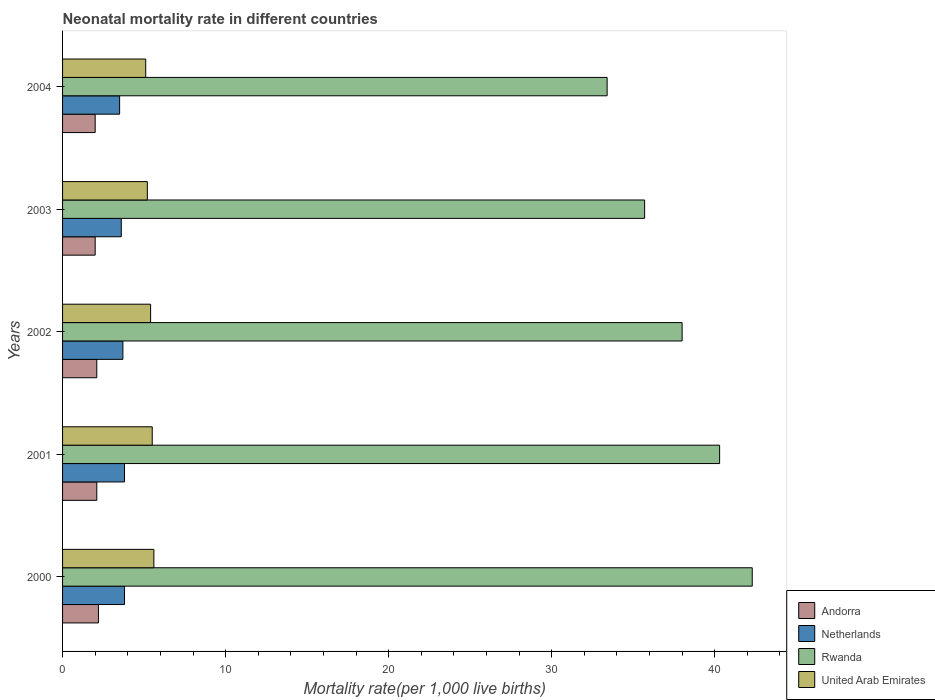How many different coloured bars are there?
Make the answer very short. 4. Are the number of bars per tick equal to the number of legend labels?
Ensure brevity in your answer.  Yes. In which year was the neonatal mortality rate in Rwanda maximum?
Ensure brevity in your answer.  2000. In which year was the neonatal mortality rate in Netherlands minimum?
Give a very brief answer. 2004. What is the difference between the neonatal mortality rate in Netherlands in 2001 and that in 2002?
Provide a succinct answer. 0.1. What is the average neonatal mortality rate in United Arab Emirates per year?
Offer a very short reply. 5.36. In the year 2000, what is the difference between the neonatal mortality rate in Rwanda and neonatal mortality rate in United Arab Emirates?
Provide a short and direct response. 36.7. In how many years, is the neonatal mortality rate in Rwanda greater than 40 ?
Give a very brief answer. 2. What is the difference between the highest and the second highest neonatal mortality rate in Netherlands?
Make the answer very short. 0. What is the difference between the highest and the lowest neonatal mortality rate in United Arab Emirates?
Provide a short and direct response. 0.5. In how many years, is the neonatal mortality rate in Andorra greater than the average neonatal mortality rate in Andorra taken over all years?
Your answer should be very brief. 3. Is the sum of the neonatal mortality rate in Rwanda in 2002 and 2004 greater than the maximum neonatal mortality rate in Netherlands across all years?
Make the answer very short. Yes. What does the 4th bar from the top in 2001 represents?
Provide a succinct answer. Andorra. What does the 1st bar from the bottom in 2003 represents?
Give a very brief answer. Andorra. Is it the case that in every year, the sum of the neonatal mortality rate in Andorra and neonatal mortality rate in United Arab Emirates is greater than the neonatal mortality rate in Netherlands?
Give a very brief answer. Yes. Are the values on the major ticks of X-axis written in scientific E-notation?
Offer a very short reply. No. Does the graph contain any zero values?
Make the answer very short. No. Does the graph contain grids?
Keep it short and to the point. No. How are the legend labels stacked?
Your answer should be very brief. Vertical. What is the title of the graph?
Your response must be concise. Neonatal mortality rate in different countries. What is the label or title of the X-axis?
Give a very brief answer. Mortality rate(per 1,0 live births). What is the label or title of the Y-axis?
Ensure brevity in your answer.  Years. What is the Mortality rate(per 1,000 live births) in Andorra in 2000?
Provide a short and direct response. 2.2. What is the Mortality rate(per 1,000 live births) of Rwanda in 2000?
Offer a terse response. 42.3. What is the Mortality rate(per 1,000 live births) of Rwanda in 2001?
Provide a succinct answer. 40.3. What is the Mortality rate(per 1,000 live births) in Netherlands in 2002?
Your answer should be compact. 3.7. What is the Mortality rate(per 1,000 live births) of Rwanda in 2003?
Give a very brief answer. 35.7. What is the Mortality rate(per 1,000 live births) in United Arab Emirates in 2003?
Make the answer very short. 5.2. What is the Mortality rate(per 1,000 live births) in Andorra in 2004?
Your answer should be very brief. 2. What is the Mortality rate(per 1,000 live births) of Rwanda in 2004?
Offer a terse response. 33.4. What is the Mortality rate(per 1,000 live births) of United Arab Emirates in 2004?
Offer a very short reply. 5.1. Across all years, what is the maximum Mortality rate(per 1,000 live births) in Netherlands?
Offer a very short reply. 3.8. Across all years, what is the maximum Mortality rate(per 1,000 live births) in Rwanda?
Your answer should be very brief. 42.3. Across all years, what is the minimum Mortality rate(per 1,000 live births) in Rwanda?
Offer a very short reply. 33.4. Across all years, what is the minimum Mortality rate(per 1,000 live births) in United Arab Emirates?
Your response must be concise. 5.1. What is the total Mortality rate(per 1,000 live births) of Netherlands in the graph?
Offer a very short reply. 18.4. What is the total Mortality rate(per 1,000 live births) in Rwanda in the graph?
Keep it short and to the point. 189.7. What is the total Mortality rate(per 1,000 live births) of United Arab Emirates in the graph?
Your answer should be compact. 26.8. What is the difference between the Mortality rate(per 1,000 live births) in Andorra in 2000 and that in 2001?
Ensure brevity in your answer.  0.1. What is the difference between the Mortality rate(per 1,000 live births) of Rwanda in 2000 and that in 2001?
Provide a short and direct response. 2. What is the difference between the Mortality rate(per 1,000 live births) in United Arab Emirates in 2000 and that in 2001?
Give a very brief answer. 0.1. What is the difference between the Mortality rate(per 1,000 live births) in Rwanda in 2000 and that in 2002?
Offer a terse response. 4.3. What is the difference between the Mortality rate(per 1,000 live births) of United Arab Emirates in 2000 and that in 2002?
Provide a short and direct response. 0.2. What is the difference between the Mortality rate(per 1,000 live births) in Andorra in 2000 and that in 2003?
Provide a short and direct response. 0.2. What is the difference between the Mortality rate(per 1,000 live births) in Netherlands in 2000 and that in 2003?
Provide a short and direct response. 0.2. What is the difference between the Mortality rate(per 1,000 live births) in Netherlands in 2000 and that in 2004?
Give a very brief answer. 0.3. What is the difference between the Mortality rate(per 1,000 live births) of United Arab Emirates in 2001 and that in 2002?
Offer a very short reply. 0.1. What is the difference between the Mortality rate(per 1,000 live births) of Andorra in 2001 and that in 2003?
Your answer should be compact. 0.1. What is the difference between the Mortality rate(per 1,000 live births) in Netherlands in 2001 and that in 2003?
Provide a succinct answer. 0.2. What is the difference between the Mortality rate(per 1,000 live births) in Andorra in 2001 and that in 2004?
Offer a very short reply. 0.1. What is the difference between the Mortality rate(per 1,000 live births) of Rwanda in 2001 and that in 2004?
Make the answer very short. 6.9. What is the difference between the Mortality rate(per 1,000 live births) of United Arab Emirates in 2001 and that in 2004?
Your response must be concise. 0.4. What is the difference between the Mortality rate(per 1,000 live births) in Andorra in 2002 and that in 2003?
Your response must be concise. 0.1. What is the difference between the Mortality rate(per 1,000 live births) in Netherlands in 2002 and that in 2003?
Provide a short and direct response. 0.1. What is the difference between the Mortality rate(per 1,000 live births) of United Arab Emirates in 2002 and that in 2003?
Ensure brevity in your answer.  0.2. What is the difference between the Mortality rate(per 1,000 live births) in United Arab Emirates in 2002 and that in 2004?
Provide a succinct answer. 0.3. What is the difference between the Mortality rate(per 1,000 live births) in Andorra in 2003 and that in 2004?
Provide a short and direct response. 0. What is the difference between the Mortality rate(per 1,000 live births) in Netherlands in 2003 and that in 2004?
Ensure brevity in your answer.  0.1. What is the difference between the Mortality rate(per 1,000 live births) in Rwanda in 2003 and that in 2004?
Offer a very short reply. 2.3. What is the difference between the Mortality rate(per 1,000 live births) in Andorra in 2000 and the Mortality rate(per 1,000 live births) in Netherlands in 2001?
Offer a very short reply. -1.6. What is the difference between the Mortality rate(per 1,000 live births) of Andorra in 2000 and the Mortality rate(per 1,000 live births) of Rwanda in 2001?
Your answer should be very brief. -38.1. What is the difference between the Mortality rate(per 1,000 live births) in Netherlands in 2000 and the Mortality rate(per 1,000 live births) in Rwanda in 2001?
Your answer should be very brief. -36.5. What is the difference between the Mortality rate(per 1,000 live births) of Netherlands in 2000 and the Mortality rate(per 1,000 live births) of United Arab Emirates in 2001?
Keep it short and to the point. -1.7. What is the difference between the Mortality rate(per 1,000 live births) in Rwanda in 2000 and the Mortality rate(per 1,000 live births) in United Arab Emirates in 2001?
Your response must be concise. 36.8. What is the difference between the Mortality rate(per 1,000 live births) of Andorra in 2000 and the Mortality rate(per 1,000 live births) of Netherlands in 2002?
Provide a short and direct response. -1.5. What is the difference between the Mortality rate(per 1,000 live births) in Andorra in 2000 and the Mortality rate(per 1,000 live births) in Rwanda in 2002?
Provide a short and direct response. -35.8. What is the difference between the Mortality rate(per 1,000 live births) in Andorra in 2000 and the Mortality rate(per 1,000 live births) in United Arab Emirates in 2002?
Your answer should be very brief. -3.2. What is the difference between the Mortality rate(per 1,000 live births) in Netherlands in 2000 and the Mortality rate(per 1,000 live births) in Rwanda in 2002?
Keep it short and to the point. -34.2. What is the difference between the Mortality rate(per 1,000 live births) of Rwanda in 2000 and the Mortality rate(per 1,000 live births) of United Arab Emirates in 2002?
Offer a very short reply. 36.9. What is the difference between the Mortality rate(per 1,000 live births) of Andorra in 2000 and the Mortality rate(per 1,000 live births) of Netherlands in 2003?
Give a very brief answer. -1.4. What is the difference between the Mortality rate(per 1,000 live births) of Andorra in 2000 and the Mortality rate(per 1,000 live births) of Rwanda in 2003?
Offer a terse response. -33.5. What is the difference between the Mortality rate(per 1,000 live births) in Andorra in 2000 and the Mortality rate(per 1,000 live births) in United Arab Emirates in 2003?
Offer a terse response. -3. What is the difference between the Mortality rate(per 1,000 live births) in Netherlands in 2000 and the Mortality rate(per 1,000 live births) in Rwanda in 2003?
Offer a very short reply. -31.9. What is the difference between the Mortality rate(per 1,000 live births) in Netherlands in 2000 and the Mortality rate(per 1,000 live births) in United Arab Emirates in 2003?
Provide a short and direct response. -1.4. What is the difference between the Mortality rate(per 1,000 live births) of Rwanda in 2000 and the Mortality rate(per 1,000 live births) of United Arab Emirates in 2003?
Your response must be concise. 37.1. What is the difference between the Mortality rate(per 1,000 live births) of Andorra in 2000 and the Mortality rate(per 1,000 live births) of Netherlands in 2004?
Your response must be concise. -1.3. What is the difference between the Mortality rate(per 1,000 live births) in Andorra in 2000 and the Mortality rate(per 1,000 live births) in Rwanda in 2004?
Provide a succinct answer. -31.2. What is the difference between the Mortality rate(per 1,000 live births) of Netherlands in 2000 and the Mortality rate(per 1,000 live births) of Rwanda in 2004?
Make the answer very short. -29.6. What is the difference between the Mortality rate(per 1,000 live births) of Rwanda in 2000 and the Mortality rate(per 1,000 live births) of United Arab Emirates in 2004?
Keep it short and to the point. 37.2. What is the difference between the Mortality rate(per 1,000 live births) of Andorra in 2001 and the Mortality rate(per 1,000 live births) of Rwanda in 2002?
Your response must be concise. -35.9. What is the difference between the Mortality rate(per 1,000 live births) of Netherlands in 2001 and the Mortality rate(per 1,000 live births) of Rwanda in 2002?
Your answer should be very brief. -34.2. What is the difference between the Mortality rate(per 1,000 live births) in Netherlands in 2001 and the Mortality rate(per 1,000 live births) in United Arab Emirates in 2002?
Keep it short and to the point. -1.6. What is the difference between the Mortality rate(per 1,000 live births) of Rwanda in 2001 and the Mortality rate(per 1,000 live births) of United Arab Emirates in 2002?
Offer a terse response. 34.9. What is the difference between the Mortality rate(per 1,000 live births) of Andorra in 2001 and the Mortality rate(per 1,000 live births) of Rwanda in 2003?
Your answer should be compact. -33.6. What is the difference between the Mortality rate(per 1,000 live births) in Andorra in 2001 and the Mortality rate(per 1,000 live births) in United Arab Emirates in 2003?
Your answer should be compact. -3.1. What is the difference between the Mortality rate(per 1,000 live births) of Netherlands in 2001 and the Mortality rate(per 1,000 live births) of Rwanda in 2003?
Provide a succinct answer. -31.9. What is the difference between the Mortality rate(per 1,000 live births) in Netherlands in 2001 and the Mortality rate(per 1,000 live births) in United Arab Emirates in 2003?
Your answer should be compact. -1.4. What is the difference between the Mortality rate(per 1,000 live births) in Rwanda in 2001 and the Mortality rate(per 1,000 live births) in United Arab Emirates in 2003?
Offer a terse response. 35.1. What is the difference between the Mortality rate(per 1,000 live births) of Andorra in 2001 and the Mortality rate(per 1,000 live births) of Rwanda in 2004?
Your answer should be compact. -31.3. What is the difference between the Mortality rate(per 1,000 live births) in Andorra in 2001 and the Mortality rate(per 1,000 live births) in United Arab Emirates in 2004?
Keep it short and to the point. -3. What is the difference between the Mortality rate(per 1,000 live births) of Netherlands in 2001 and the Mortality rate(per 1,000 live births) of Rwanda in 2004?
Give a very brief answer. -29.6. What is the difference between the Mortality rate(per 1,000 live births) in Netherlands in 2001 and the Mortality rate(per 1,000 live births) in United Arab Emirates in 2004?
Provide a short and direct response. -1.3. What is the difference between the Mortality rate(per 1,000 live births) of Rwanda in 2001 and the Mortality rate(per 1,000 live births) of United Arab Emirates in 2004?
Your response must be concise. 35.2. What is the difference between the Mortality rate(per 1,000 live births) of Andorra in 2002 and the Mortality rate(per 1,000 live births) of Rwanda in 2003?
Your answer should be very brief. -33.6. What is the difference between the Mortality rate(per 1,000 live births) in Netherlands in 2002 and the Mortality rate(per 1,000 live births) in Rwanda in 2003?
Ensure brevity in your answer.  -32. What is the difference between the Mortality rate(per 1,000 live births) of Netherlands in 2002 and the Mortality rate(per 1,000 live births) of United Arab Emirates in 2003?
Your response must be concise. -1.5. What is the difference between the Mortality rate(per 1,000 live births) of Rwanda in 2002 and the Mortality rate(per 1,000 live births) of United Arab Emirates in 2003?
Provide a succinct answer. 32.8. What is the difference between the Mortality rate(per 1,000 live births) of Andorra in 2002 and the Mortality rate(per 1,000 live births) of Rwanda in 2004?
Your answer should be compact. -31.3. What is the difference between the Mortality rate(per 1,000 live births) in Netherlands in 2002 and the Mortality rate(per 1,000 live births) in Rwanda in 2004?
Give a very brief answer. -29.7. What is the difference between the Mortality rate(per 1,000 live births) of Netherlands in 2002 and the Mortality rate(per 1,000 live births) of United Arab Emirates in 2004?
Make the answer very short. -1.4. What is the difference between the Mortality rate(per 1,000 live births) in Rwanda in 2002 and the Mortality rate(per 1,000 live births) in United Arab Emirates in 2004?
Ensure brevity in your answer.  32.9. What is the difference between the Mortality rate(per 1,000 live births) in Andorra in 2003 and the Mortality rate(per 1,000 live births) in Netherlands in 2004?
Keep it short and to the point. -1.5. What is the difference between the Mortality rate(per 1,000 live births) of Andorra in 2003 and the Mortality rate(per 1,000 live births) of Rwanda in 2004?
Ensure brevity in your answer.  -31.4. What is the difference between the Mortality rate(per 1,000 live births) of Netherlands in 2003 and the Mortality rate(per 1,000 live births) of Rwanda in 2004?
Your response must be concise. -29.8. What is the difference between the Mortality rate(per 1,000 live births) of Rwanda in 2003 and the Mortality rate(per 1,000 live births) of United Arab Emirates in 2004?
Make the answer very short. 30.6. What is the average Mortality rate(per 1,000 live births) of Andorra per year?
Your answer should be compact. 2.08. What is the average Mortality rate(per 1,000 live births) in Netherlands per year?
Offer a terse response. 3.68. What is the average Mortality rate(per 1,000 live births) of Rwanda per year?
Your answer should be compact. 37.94. What is the average Mortality rate(per 1,000 live births) of United Arab Emirates per year?
Keep it short and to the point. 5.36. In the year 2000, what is the difference between the Mortality rate(per 1,000 live births) in Andorra and Mortality rate(per 1,000 live births) in Netherlands?
Offer a terse response. -1.6. In the year 2000, what is the difference between the Mortality rate(per 1,000 live births) of Andorra and Mortality rate(per 1,000 live births) of Rwanda?
Provide a short and direct response. -40.1. In the year 2000, what is the difference between the Mortality rate(per 1,000 live births) in Andorra and Mortality rate(per 1,000 live births) in United Arab Emirates?
Make the answer very short. -3.4. In the year 2000, what is the difference between the Mortality rate(per 1,000 live births) of Netherlands and Mortality rate(per 1,000 live births) of Rwanda?
Ensure brevity in your answer.  -38.5. In the year 2000, what is the difference between the Mortality rate(per 1,000 live births) of Netherlands and Mortality rate(per 1,000 live births) of United Arab Emirates?
Provide a succinct answer. -1.8. In the year 2000, what is the difference between the Mortality rate(per 1,000 live births) in Rwanda and Mortality rate(per 1,000 live births) in United Arab Emirates?
Your answer should be compact. 36.7. In the year 2001, what is the difference between the Mortality rate(per 1,000 live births) of Andorra and Mortality rate(per 1,000 live births) of Netherlands?
Your answer should be compact. -1.7. In the year 2001, what is the difference between the Mortality rate(per 1,000 live births) of Andorra and Mortality rate(per 1,000 live births) of Rwanda?
Provide a short and direct response. -38.2. In the year 2001, what is the difference between the Mortality rate(per 1,000 live births) of Andorra and Mortality rate(per 1,000 live births) of United Arab Emirates?
Offer a very short reply. -3.4. In the year 2001, what is the difference between the Mortality rate(per 1,000 live births) of Netherlands and Mortality rate(per 1,000 live births) of Rwanda?
Your answer should be very brief. -36.5. In the year 2001, what is the difference between the Mortality rate(per 1,000 live births) in Rwanda and Mortality rate(per 1,000 live births) in United Arab Emirates?
Provide a succinct answer. 34.8. In the year 2002, what is the difference between the Mortality rate(per 1,000 live births) of Andorra and Mortality rate(per 1,000 live births) of Rwanda?
Ensure brevity in your answer.  -35.9. In the year 2002, what is the difference between the Mortality rate(per 1,000 live births) in Netherlands and Mortality rate(per 1,000 live births) in Rwanda?
Your answer should be very brief. -34.3. In the year 2002, what is the difference between the Mortality rate(per 1,000 live births) of Netherlands and Mortality rate(per 1,000 live births) of United Arab Emirates?
Offer a very short reply. -1.7. In the year 2002, what is the difference between the Mortality rate(per 1,000 live births) of Rwanda and Mortality rate(per 1,000 live births) of United Arab Emirates?
Your answer should be compact. 32.6. In the year 2003, what is the difference between the Mortality rate(per 1,000 live births) in Andorra and Mortality rate(per 1,000 live births) in Netherlands?
Your answer should be compact. -1.6. In the year 2003, what is the difference between the Mortality rate(per 1,000 live births) of Andorra and Mortality rate(per 1,000 live births) of Rwanda?
Make the answer very short. -33.7. In the year 2003, what is the difference between the Mortality rate(per 1,000 live births) in Netherlands and Mortality rate(per 1,000 live births) in Rwanda?
Your answer should be very brief. -32.1. In the year 2003, what is the difference between the Mortality rate(per 1,000 live births) in Netherlands and Mortality rate(per 1,000 live births) in United Arab Emirates?
Provide a short and direct response. -1.6. In the year 2003, what is the difference between the Mortality rate(per 1,000 live births) of Rwanda and Mortality rate(per 1,000 live births) of United Arab Emirates?
Your response must be concise. 30.5. In the year 2004, what is the difference between the Mortality rate(per 1,000 live births) of Andorra and Mortality rate(per 1,000 live births) of Netherlands?
Ensure brevity in your answer.  -1.5. In the year 2004, what is the difference between the Mortality rate(per 1,000 live births) in Andorra and Mortality rate(per 1,000 live births) in Rwanda?
Provide a succinct answer. -31.4. In the year 2004, what is the difference between the Mortality rate(per 1,000 live births) of Netherlands and Mortality rate(per 1,000 live births) of Rwanda?
Your response must be concise. -29.9. In the year 2004, what is the difference between the Mortality rate(per 1,000 live births) in Netherlands and Mortality rate(per 1,000 live births) in United Arab Emirates?
Your answer should be compact. -1.6. In the year 2004, what is the difference between the Mortality rate(per 1,000 live births) in Rwanda and Mortality rate(per 1,000 live births) in United Arab Emirates?
Keep it short and to the point. 28.3. What is the ratio of the Mortality rate(per 1,000 live births) in Andorra in 2000 to that in 2001?
Your response must be concise. 1.05. What is the ratio of the Mortality rate(per 1,000 live births) of Rwanda in 2000 to that in 2001?
Offer a very short reply. 1.05. What is the ratio of the Mortality rate(per 1,000 live births) in United Arab Emirates in 2000 to that in 2001?
Offer a very short reply. 1.02. What is the ratio of the Mortality rate(per 1,000 live births) of Andorra in 2000 to that in 2002?
Offer a very short reply. 1.05. What is the ratio of the Mortality rate(per 1,000 live births) in Rwanda in 2000 to that in 2002?
Ensure brevity in your answer.  1.11. What is the ratio of the Mortality rate(per 1,000 live births) in United Arab Emirates in 2000 to that in 2002?
Your answer should be very brief. 1.04. What is the ratio of the Mortality rate(per 1,000 live births) of Netherlands in 2000 to that in 2003?
Provide a succinct answer. 1.06. What is the ratio of the Mortality rate(per 1,000 live births) of Rwanda in 2000 to that in 2003?
Ensure brevity in your answer.  1.18. What is the ratio of the Mortality rate(per 1,000 live births) in United Arab Emirates in 2000 to that in 2003?
Offer a terse response. 1.08. What is the ratio of the Mortality rate(per 1,000 live births) in Andorra in 2000 to that in 2004?
Provide a succinct answer. 1.1. What is the ratio of the Mortality rate(per 1,000 live births) in Netherlands in 2000 to that in 2004?
Offer a terse response. 1.09. What is the ratio of the Mortality rate(per 1,000 live births) of Rwanda in 2000 to that in 2004?
Keep it short and to the point. 1.27. What is the ratio of the Mortality rate(per 1,000 live births) in United Arab Emirates in 2000 to that in 2004?
Your response must be concise. 1.1. What is the ratio of the Mortality rate(per 1,000 live births) in Rwanda in 2001 to that in 2002?
Provide a succinct answer. 1.06. What is the ratio of the Mortality rate(per 1,000 live births) in United Arab Emirates in 2001 to that in 2002?
Your answer should be compact. 1.02. What is the ratio of the Mortality rate(per 1,000 live births) of Andorra in 2001 to that in 2003?
Keep it short and to the point. 1.05. What is the ratio of the Mortality rate(per 1,000 live births) of Netherlands in 2001 to that in 2003?
Ensure brevity in your answer.  1.06. What is the ratio of the Mortality rate(per 1,000 live births) in Rwanda in 2001 to that in 2003?
Your answer should be compact. 1.13. What is the ratio of the Mortality rate(per 1,000 live births) in United Arab Emirates in 2001 to that in 2003?
Keep it short and to the point. 1.06. What is the ratio of the Mortality rate(per 1,000 live births) of Netherlands in 2001 to that in 2004?
Make the answer very short. 1.09. What is the ratio of the Mortality rate(per 1,000 live births) in Rwanda in 2001 to that in 2004?
Your answer should be very brief. 1.21. What is the ratio of the Mortality rate(per 1,000 live births) of United Arab Emirates in 2001 to that in 2004?
Your answer should be compact. 1.08. What is the ratio of the Mortality rate(per 1,000 live births) in Andorra in 2002 to that in 2003?
Offer a terse response. 1.05. What is the ratio of the Mortality rate(per 1,000 live births) in Netherlands in 2002 to that in 2003?
Your answer should be compact. 1.03. What is the ratio of the Mortality rate(per 1,000 live births) of Rwanda in 2002 to that in 2003?
Offer a terse response. 1.06. What is the ratio of the Mortality rate(per 1,000 live births) in United Arab Emirates in 2002 to that in 2003?
Give a very brief answer. 1.04. What is the ratio of the Mortality rate(per 1,000 live births) in Netherlands in 2002 to that in 2004?
Keep it short and to the point. 1.06. What is the ratio of the Mortality rate(per 1,000 live births) in Rwanda in 2002 to that in 2004?
Make the answer very short. 1.14. What is the ratio of the Mortality rate(per 1,000 live births) in United Arab Emirates in 2002 to that in 2004?
Your answer should be compact. 1.06. What is the ratio of the Mortality rate(per 1,000 live births) of Netherlands in 2003 to that in 2004?
Provide a short and direct response. 1.03. What is the ratio of the Mortality rate(per 1,000 live births) in Rwanda in 2003 to that in 2004?
Your answer should be compact. 1.07. What is the ratio of the Mortality rate(per 1,000 live births) of United Arab Emirates in 2003 to that in 2004?
Offer a very short reply. 1.02. What is the difference between the highest and the lowest Mortality rate(per 1,000 live births) in Netherlands?
Offer a very short reply. 0.3. What is the difference between the highest and the lowest Mortality rate(per 1,000 live births) in Rwanda?
Offer a terse response. 8.9. What is the difference between the highest and the lowest Mortality rate(per 1,000 live births) in United Arab Emirates?
Make the answer very short. 0.5. 